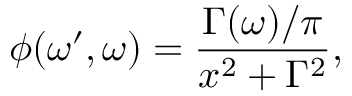<formula> <loc_0><loc_0><loc_500><loc_500>\phi ( \omega ^ { \prime } , \omega ) = \frac { \Gamma ( \omega ) / \pi } { x ^ { 2 } + \Gamma ^ { 2 } } ,</formula> 